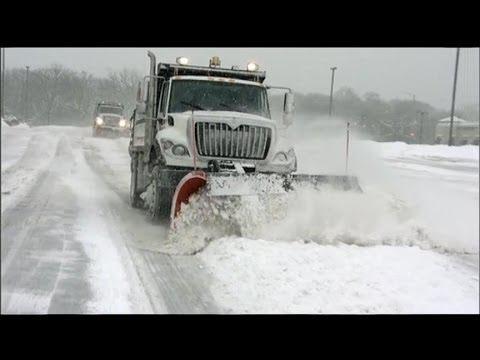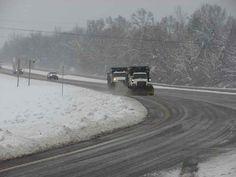The first image is the image on the left, the second image is the image on the right. Evaluate the accuracy of this statement regarding the images: "In one of the images, a red vehicle is pushing and clearing snow.". Is it true? Answer yes or no. No. The first image is the image on the left, the second image is the image on the right. For the images displayed, is the sentence "Right image includes a camera-facing plow truck driving toward a curve in a snowy road scene." factually correct? Answer yes or no. Yes. 